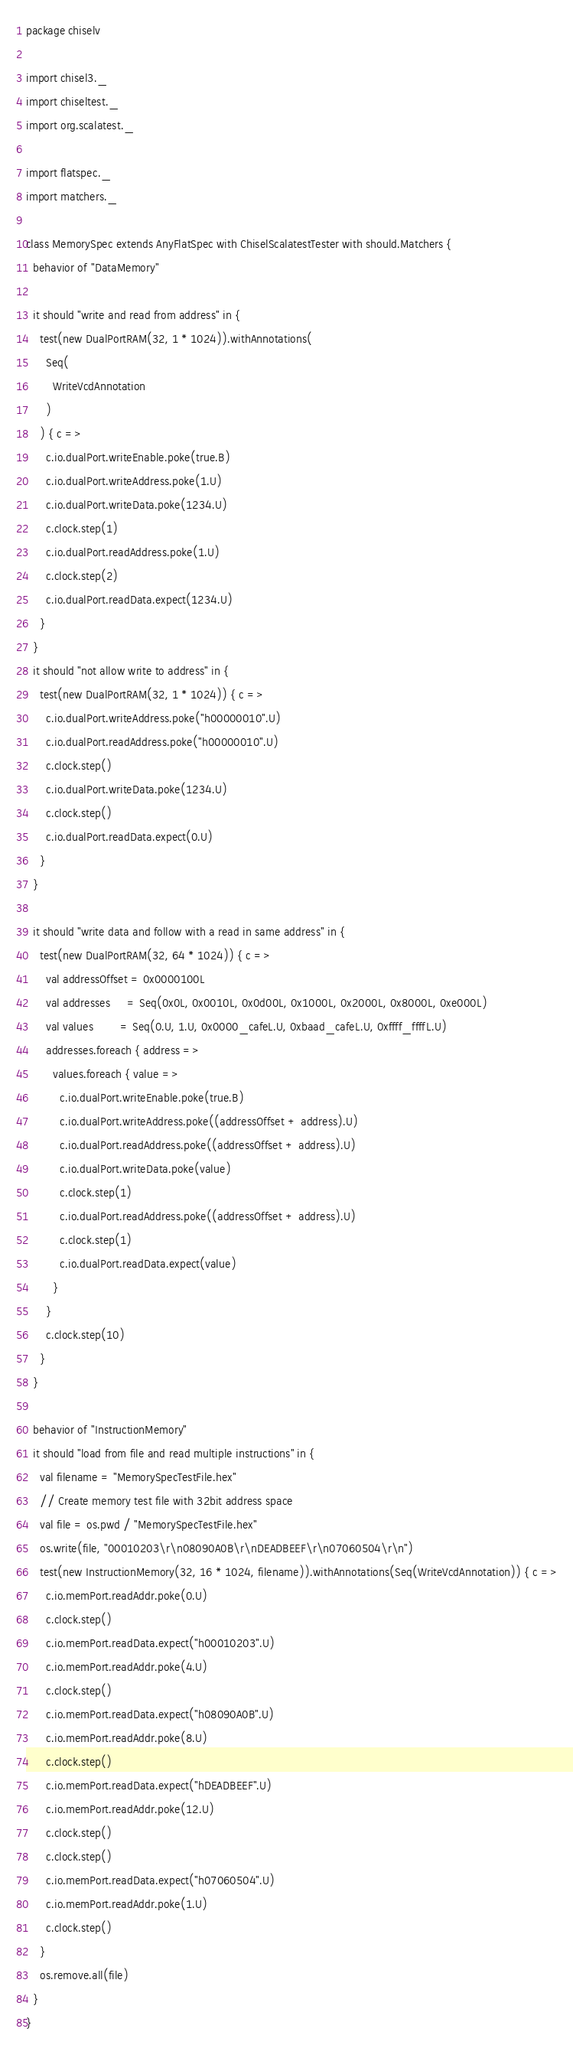Convert code to text. <code><loc_0><loc_0><loc_500><loc_500><_Scala_>package chiselv

import chisel3._
import chiseltest._
import org.scalatest._

import flatspec._
import matchers._

class MemorySpec extends AnyFlatSpec with ChiselScalatestTester with should.Matchers {
  behavior of "DataMemory"

  it should "write and read from address" in {
    test(new DualPortRAM(32, 1 * 1024)).withAnnotations(
      Seq(
        WriteVcdAnnotation
      )
    ) { c =>
      c.io.dualPort.writeEnable.poke(true.B)
      c.io.dualPort.writeAddress.poke(1.U)
      c.io.dualPort.writeData.poke(1234.U)
      c.clock.step(1)
      c.io.dualPort.readAddress.poke(1.U)
      c.clock.step(2)
      c.io.dualPort.readData.expect(1234.U)
    }
  }
  it should "not allow write to address" in {
    test(new DualPortRAM(32, 1 * 1024)) { c =>
      c.io.dualPort.writeAddress.poke("h00000010".U)
      c.io.dualPort.readAddress.poke("h00000010".U)
      c.clock.step()
      c.io.dualPort.writeData.poke(1234.U)
      c.clock.step()
      c.io.dualPort.readData.expect(0.U)
    }
  }

  it should "write data and follow with a read in same address" in {
    test(new DualPortRAM(32, 64 * 1024)) { c =>
      val addressOffset = 0x0000100L
      val addresses     = Seq(0x0L, 0x0010L, 0x0d00L, 0x1000L, 0x2000L, 0x8000L, 0xe000L)
      val values        = Seq(0.U, 1.U, 0x0000_cafeL.U, 0xbaad_cafeL.U, 0xffff_ffffL.U)
      addresses.foreach { address =>
        values.foreach { value =>
          c.io.dualPort.writeEnable.poke(true.B)
          c.io.dualPort.writeAddress.poke((addressOffset + address).U)
          c.io.dualPort.readAddress.poke((addressOffset + address).U)
          c.io.dualPort.writeData.poke(value)
          c.clock.step(1)
          c.io.dualPort.readAddress.poke((addressOffset + address).U)
          c.clock.step(1)
          c.io.dualPort.readData.expect(value)
        }
      }
      c.clock.step(10)
    }
  }

  behavior of "InstructionMemory"
  it should "load from file and read multiple instructions" in {
    val filename = "MemorySpecTestFile.hex"
    // Create memory test file with 32bit address space
    val file = os.pwd / "MemorySpecTestFile.hex"
    os.write(file, "00010203\r\n08090A0B\r\nDEADBEEF\r\n07060504\r\n")
    test(new InstructionMemory(32, 16 * 1024, filename)).withAnnotations(Seq(WriteVcdAnnotation)) { c =>
      c.io.memPort.readAddr.poke(0.U)
      c.clock.step()
      c.io.memPort.readData.expect("h00010203".U)
      c.io.memPort.readAddr.poke(4.U)
      c.clock.step()
      c.io.memPort.readData.expect("h08090A0B".U)
      c.io.memPort.readAddr.poke(8.U)
      c.clock.step()
      c.io.memPort.readData.expect("hDEADBEEF".U)
      c.io.memPort.readAddr.poke(12.U)
      c.clock.step()
      c.clock.step()
      c.io.memPort.readData.expect("h07060504".U)
      c.io.memPort.readAddr.poke(1.U)
      c.clock.step()
    }
    os.remove.all(file)
  }
}
</code> 